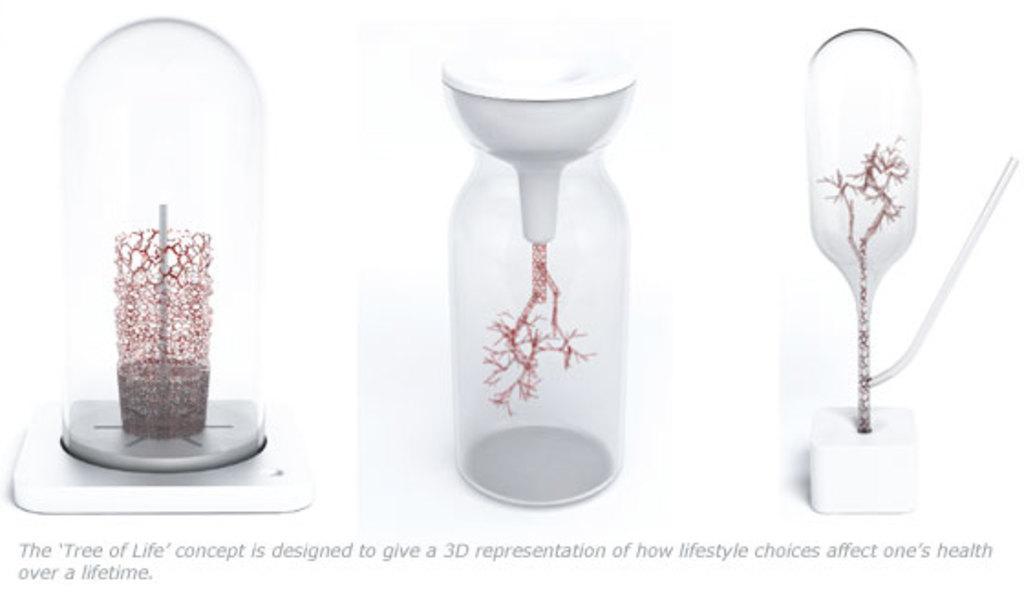Please provide a concise description of this image. There three 3D printings of some objects and there is a text. And the background of this image is white in color. 